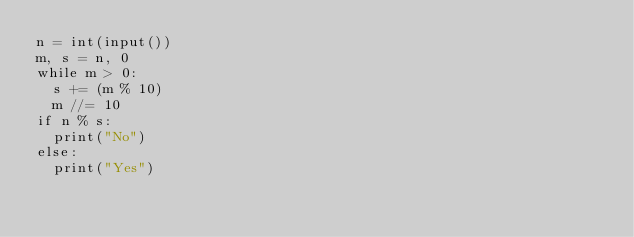Convert code to text. <code><loc_0><loc_0><loc_500><loc_500><_Python_>n = int(input())
m, s = n, 0
while m > 0:
  s += (m % 10)
  m //= 10
if n % s:
  print("No")
else:
  print("Yes")</code> 